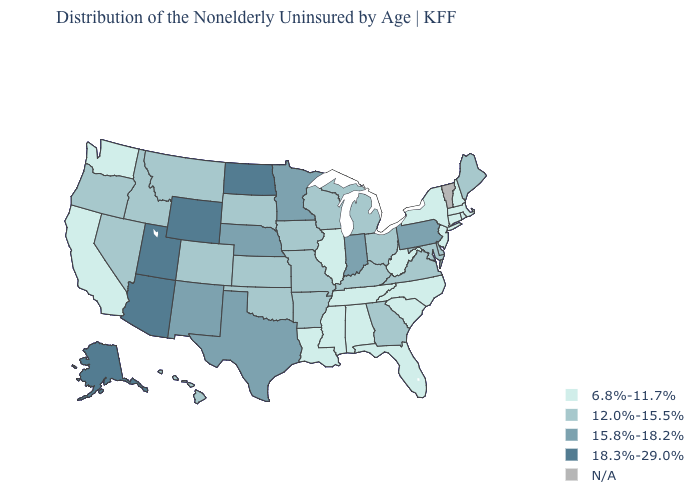Does Indiana have the highest value in the MidWest?
Write a very short answer. No. How many symbols are there in the legend?
Quick response, please. 5. What is the highest value in states that border Colorado?
Short answer required. 18.3%-29.0%. How many symbols are there in the legend?
Quick response, please. 5. Name the states that have a value in the range 12.0%-15.5%?
Concise answer only. Arkansas, Colorado, Delaware, Georgia, Hawaii, Idaho, Iowa, Kansas, Kentucky, Maine, Maryland, Michigan, Missouri, Montana, Nevada, Ohio, Oklahoma, Oregon, South Dakota, Virginia, Wisconsin. Which states hav the highest value in the South?
Short answer required. Texas. Which states have the highest value in the USA?
Keep it brief. Alaska, Arizona, North Dakota, Utah, Wyoming. What is the value of Michigan?
Answer briefly. 12.0%-15.5%. What is the lowest value in the South?
Answer briefly. 6.8%-11.7%. What is the value of Wisconsin?
Answer briefly. 12.0%-15.5%. Name the states that have a value in the range 12.0%-15.5%?
Be succinct. Arkansas, Colorado, Delaware, Georgia, Hawaii, Idaho, Iowa, Kansas, Kentucky, Maine, Maryland, Michigan, Missouri, Montana, Nevada, Ohio, Oklahoma, Oregon, South Dakota, Virginia, Wisconsin. Name the states that have a value in the range N/A?
Short answer required. Vermont. Does Washington have the lowest value in the West?
Quick response, please. Yes. 